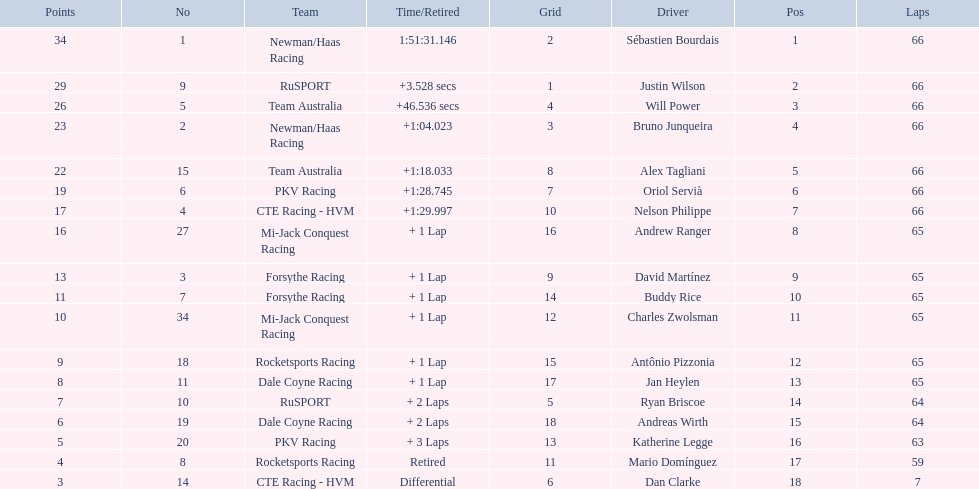What are the drivers numbers? 1, 9, 5, 2, 15, 6, 4, 27, 3, 7, 34, 18, 11, 10, 19, 20, 8, 14. Are there any who's number matches his position? Sébastien Bourdais, Oriol Servià. Of those two who has the highest position? Sébastien Bourdais. 